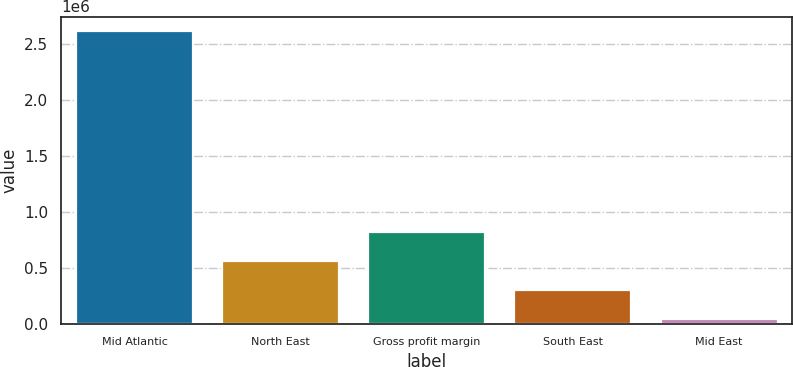Convert chart to OTSL. <chart><loc_0><loc_0><loc_500><loc_500><bar_chart><fcel>Mid Atlantic<fcel>North East<fcel>Gross profit margin<fcel>South East<fcel>Mid East<nl><fcel>2.61711e+06<fcel>561452<fcel>818409<fcel>304495<fcel>47538<nl></chart> 